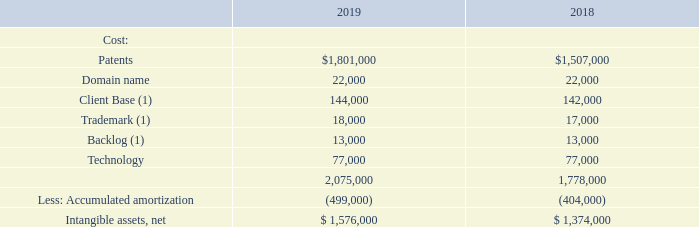NOTE 6—INTANGIBLE ASSETS, NET, AND GOODWILL
Intangible assets include patents, domain name and other intangibles purchased from GVR, including customer relationships, technology and a trademark. Certain patents were acquired from STI as a result of an asset contribution and were recorded at their carryover basis. The fair value of the patents remained substantially the same as their carrying value at the exchange date. In addition, we acquired other patents and the domain name www.resonant.com through the normal course of business. Intangibles acquired as part of the purchase of GVR were initially recorded at their fair value. Issued patents are amortized over their approximate useful life of 17 years, or 20 years in the case of new patents, once they are approved by their respective regulatory agency. For the patents acquired from STI, we are amortizing them over the remaining useful life of 1 to 11 years as of December 31, 2019. The domain name is amortized over the approximate useful life of 10 years. The other intangibles acquired from GVR are amortized over their useful life of three to five years.
Intangible assets, net, consists of the following as of December 31, 2019 and 2018:
(1) Includes the impact of foreign currency translation. The total impact at December 31, 2018 was $1,000 and there was no impact at December 31,
2019.
During the year ended December 31, 2019 and 2018, we wrote-off $145,000 and $96,000, respectively, of patents we are no longer pursuing. The write-offs are included in research and development expense. There were no impairments to any other intangibles.
What are the components recorded under cost for intangible assets? Patents, domain name, client base, trademark, backlog, technology. What was the impact of foreign currency translation to the cost components in 2019? No impact. How many years was the domain name amortized over? Approximate useful life of 10 years. Which year was the cost for patents lower? $1,507,000 < $1,801,000  
Answer: 2018. What was the change in total cost? 2,075,000 - 1,778,000 
Answer: 297000. What was the percentage change in net intangible assets?
Answer scale should be: percent. ($1,576,000 - $ 1,374,000)/$ 1,374,000 
Answer: 14.7. 